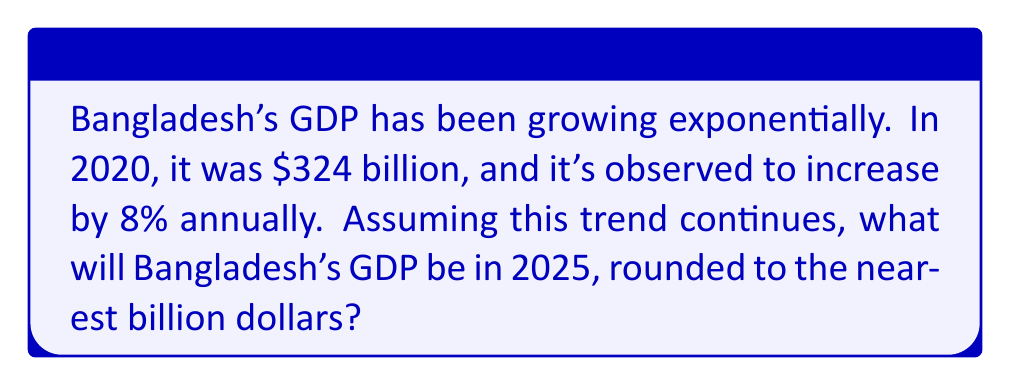Provide a solution to this math problem. Let's approach this step-by-step:

1) The initial GDP (2020): $324 billion
2) Annual growth rate: 8% = 0.08
3) Number of years from 2020 to 2025: 5 years

We can use the exponential growth formula:
$$A = P(1 + r)^n$$
Where:
$A$ = Final amount
$P$ = Initial principal balance
$r$ = Annual growth rate (as a decimal)
$n$ = Number of years

Plugging in our values:
$$A = 324(1 + 0.08)^5$$

Let's calculate:
$$A = 324(1.08)^5$$
$$A = 324(1.469328)$$
$$A = 475.662272 \text{ billion}$$

Rounding to the nearest billion:
$$A \approx 476 \text{ billion dollars}$$
Answer: $476 billion 